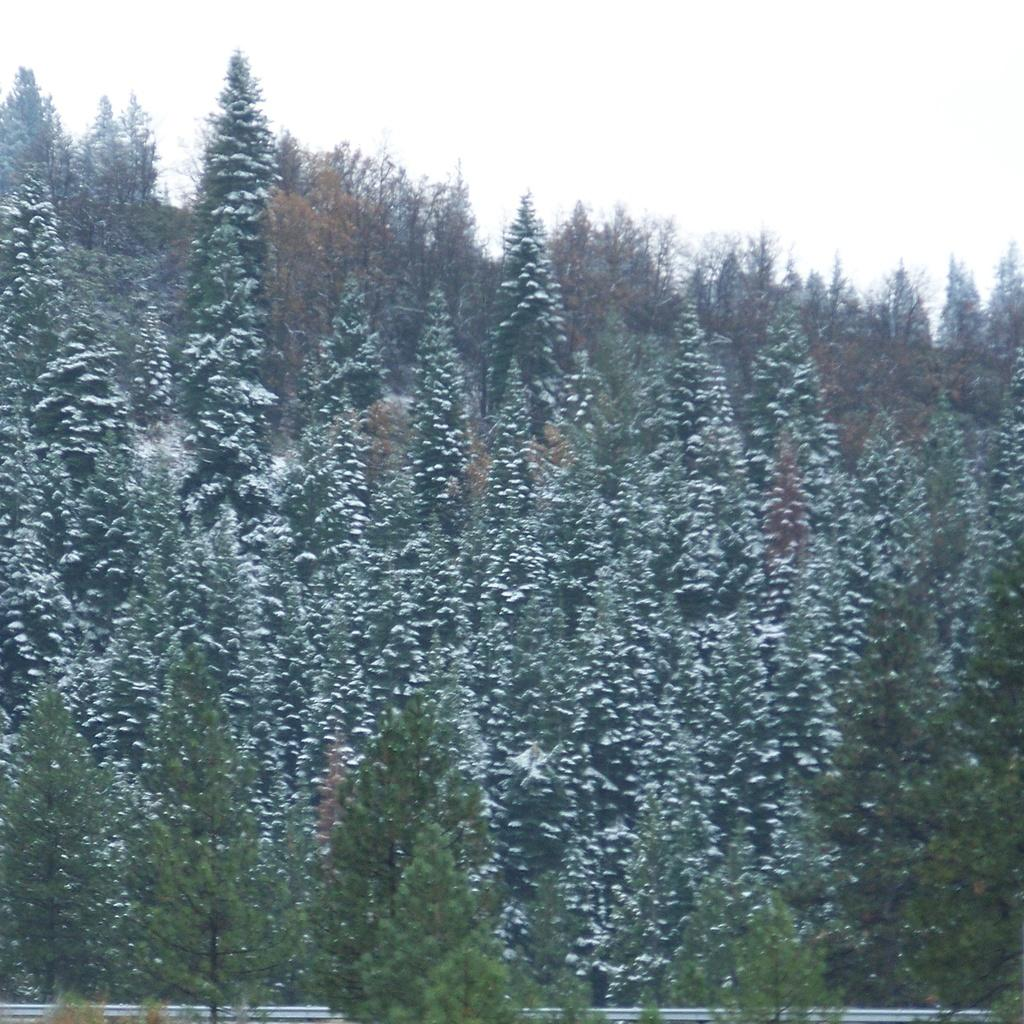What type of vegetation is in the middle of the image? There are trees in the middle of the image. What object can be seen at the bottom of the image? There is an iron rod at the bottom of the image. What is visible at the top of the image? The sky is visible at the top of the image. What type of wood can be seen forming a border around the image? There is no wood or border present in the image; it only features trees, an iron rod, and the sky. What type of stone is visible at the bottom of the image? There is no stone present in the image; it features an iron rod at the bottom. 